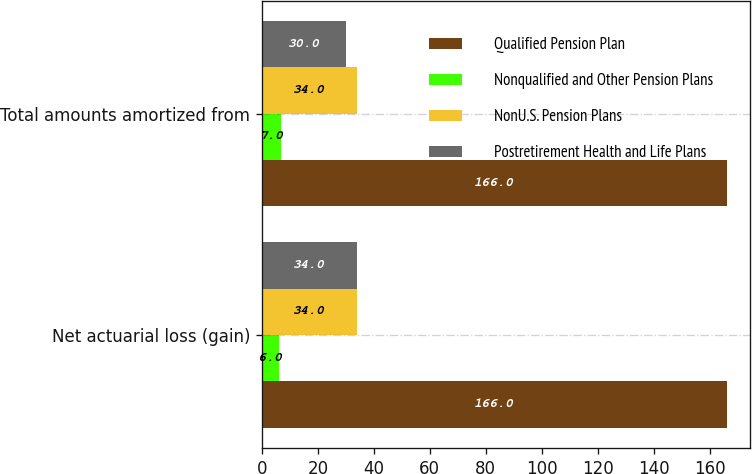Convert chart to OTSL. <chart><loc_0><loc_0><loc_500><loc_500><stacked_bar_chart><ecel><fcel>Net actuarial loss (gain)<fcel>Total amounts amortized from<nl><fcel>Qualified Pension Plan<fcel>166<fcel>166<nl><fcel>Nonqualified and Other Pension Plans<fcel>6<fcel>7<nl><fcel>NonU.S. Pension Plans<fcel>34<fcel>34<nl><fcel>Postretirement Health and Life Plans<fcel>34<fcel>30<nl></chart> 